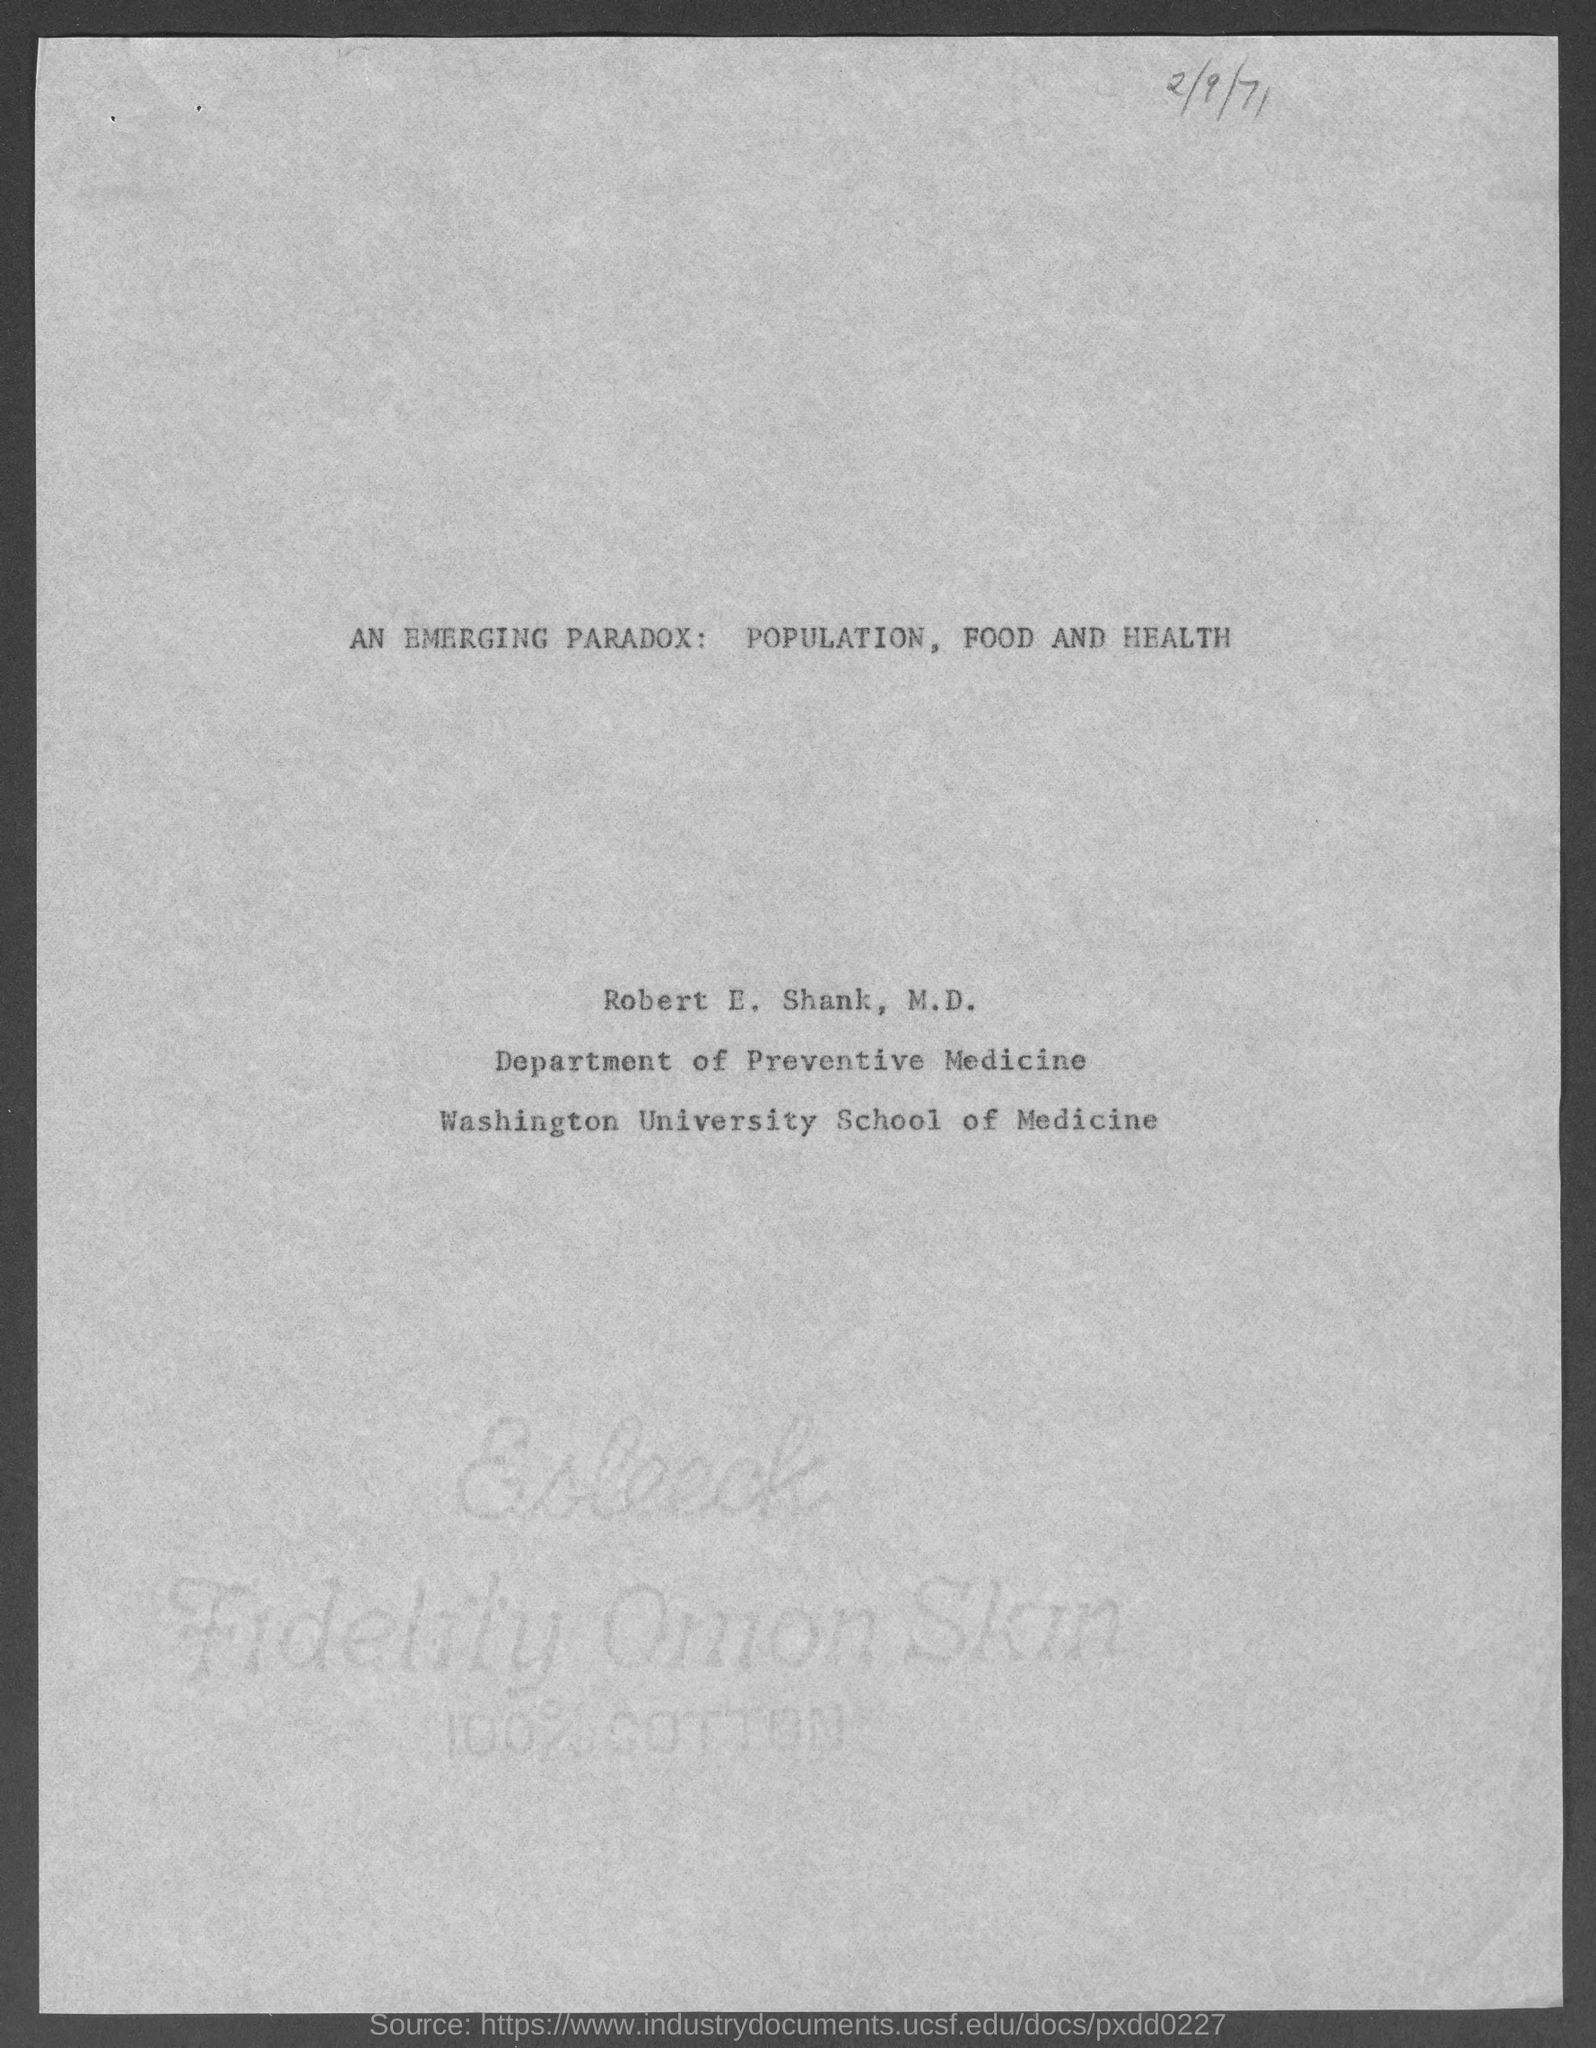Indicate a few pertinent items in this graphic. The date mentioned in this document is February 9, 1971. Robert E. Shank, M.D. works in the Department of Preventive Medicine. 